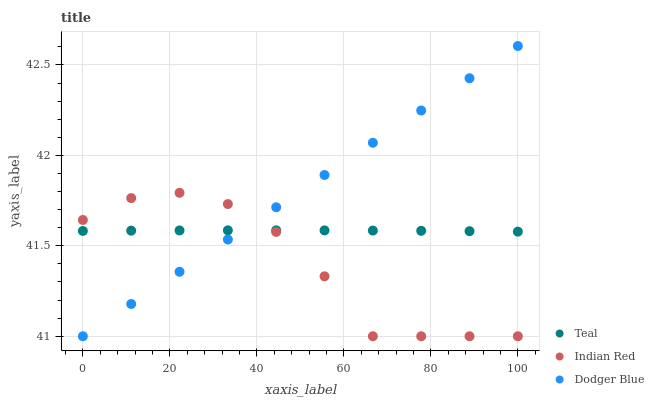Does Indian Red have the minimum area under the curve?
Answer yes or no. Yes. Does Dodger Blue have the maximum area under the curve?
Answer yes or no. Yes. Does Teal have the minimum area under the curve?
Answer yes or no. No. Does Teal have the maximum area under the curve?
Answer yes or no. No. Is Dodger Blue the smoothest?
Answer yes or no. Yes. Is Indian Red the roughest?
Answer yes or no. Yes. Is Teal the smoothest?
Answer yes or no. No. Is Teal the roughest?
Answer yes or no. No. Does Dodger Blue have the lowest value?
Answer yes or no. Yes. Does Teal have the lowest value?
Answer yes or no. No. Does Dodger Blue have the highest value?
Answer yes or no. Yes. Does Indian Red have the highest value?
Answer yes or no. No. Does Teal intersect Dodger Blue?
Answer yes or no. Yes. Is Teal less than Dodger Blue?
Answer yes or no. No. Is Teal greater than Dodger Blue?
Answer yes or no. No. 